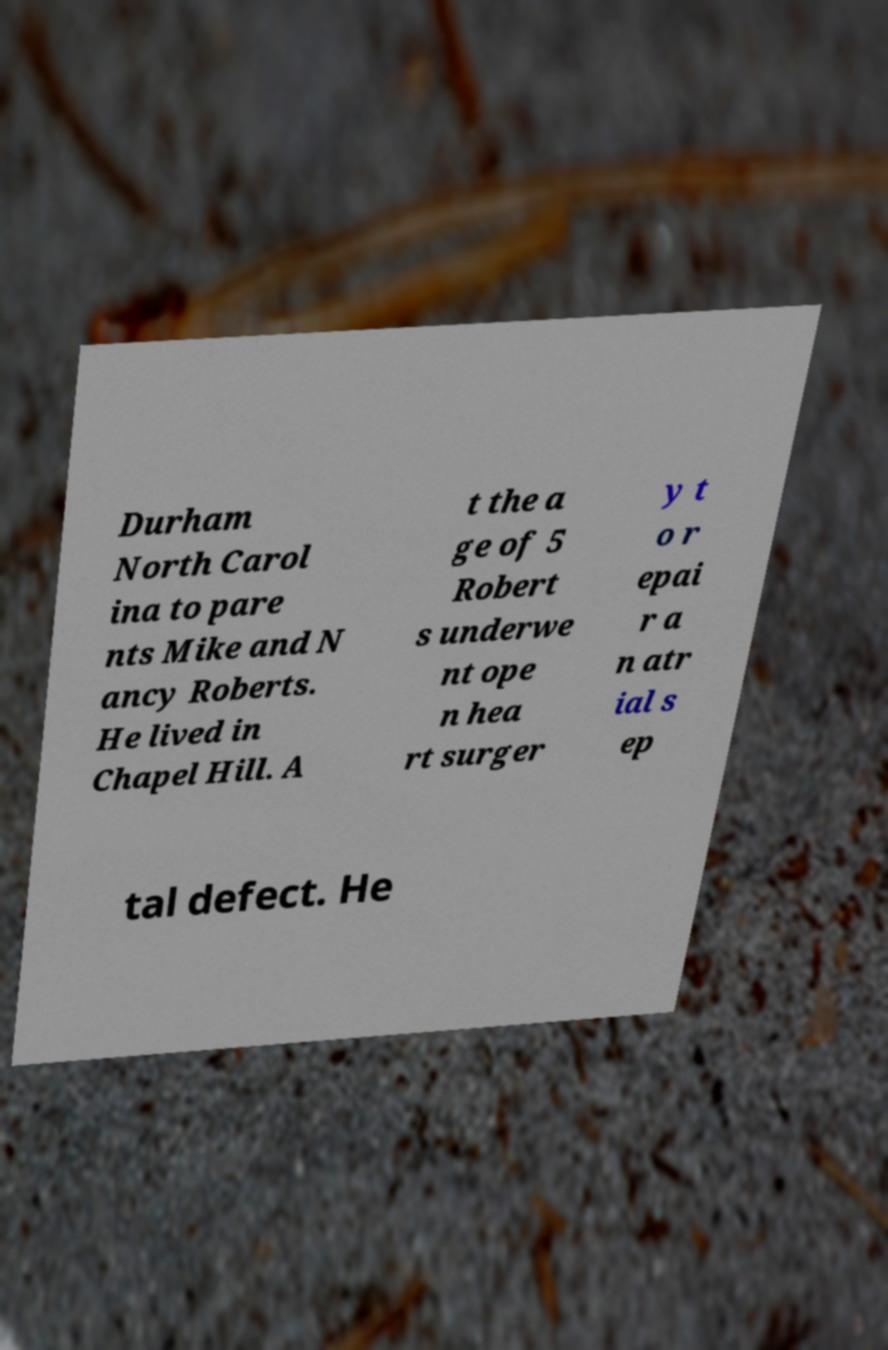Please read and relay the text visible in this image. What does it say? Durham North Carol ina to pare nts Mike and N ancy Roberts. He lived in Chapel Hill. A t the a ge of 5 Robert s underwe nt ope n hea rt surger y t o r epai r a n atr ial s ep tal defect. He 